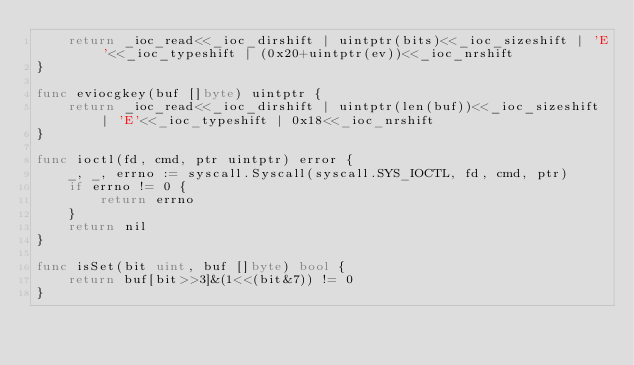<code> <loc_0><loc_0><loc_500><loc_500><_Go_>	return _ioc_read<<_ioc_dirshift | uintptr(bits)<<_ioc_sizeshift | 'E'<<_ioc_typeshift | (0x20+uintptr(ev))<<_ioc_nrshift
}

func eviocgkey(buf []byte) uintptr {
	return _ioc_read<<_ioc_dirshift | uintptr(len(buf))<<_ioc_sizeshift | 'E'<<_ioc_typeshift | 0x18<<_ioc_nrshift
}

func ioctl(fd, cmd, ptr uintptr) error {
	_, _, errno := syscall.Syscall(syscall.SYS_IOCTL, fd, cmd, ptr)
	if errno != 0 {
		return errno
	}
	return nil
}

func isSet(bit uint, buf []byte) bool {
	return buf[bit>>3]&(1<<(bit&7)) != 0
}
</code> 